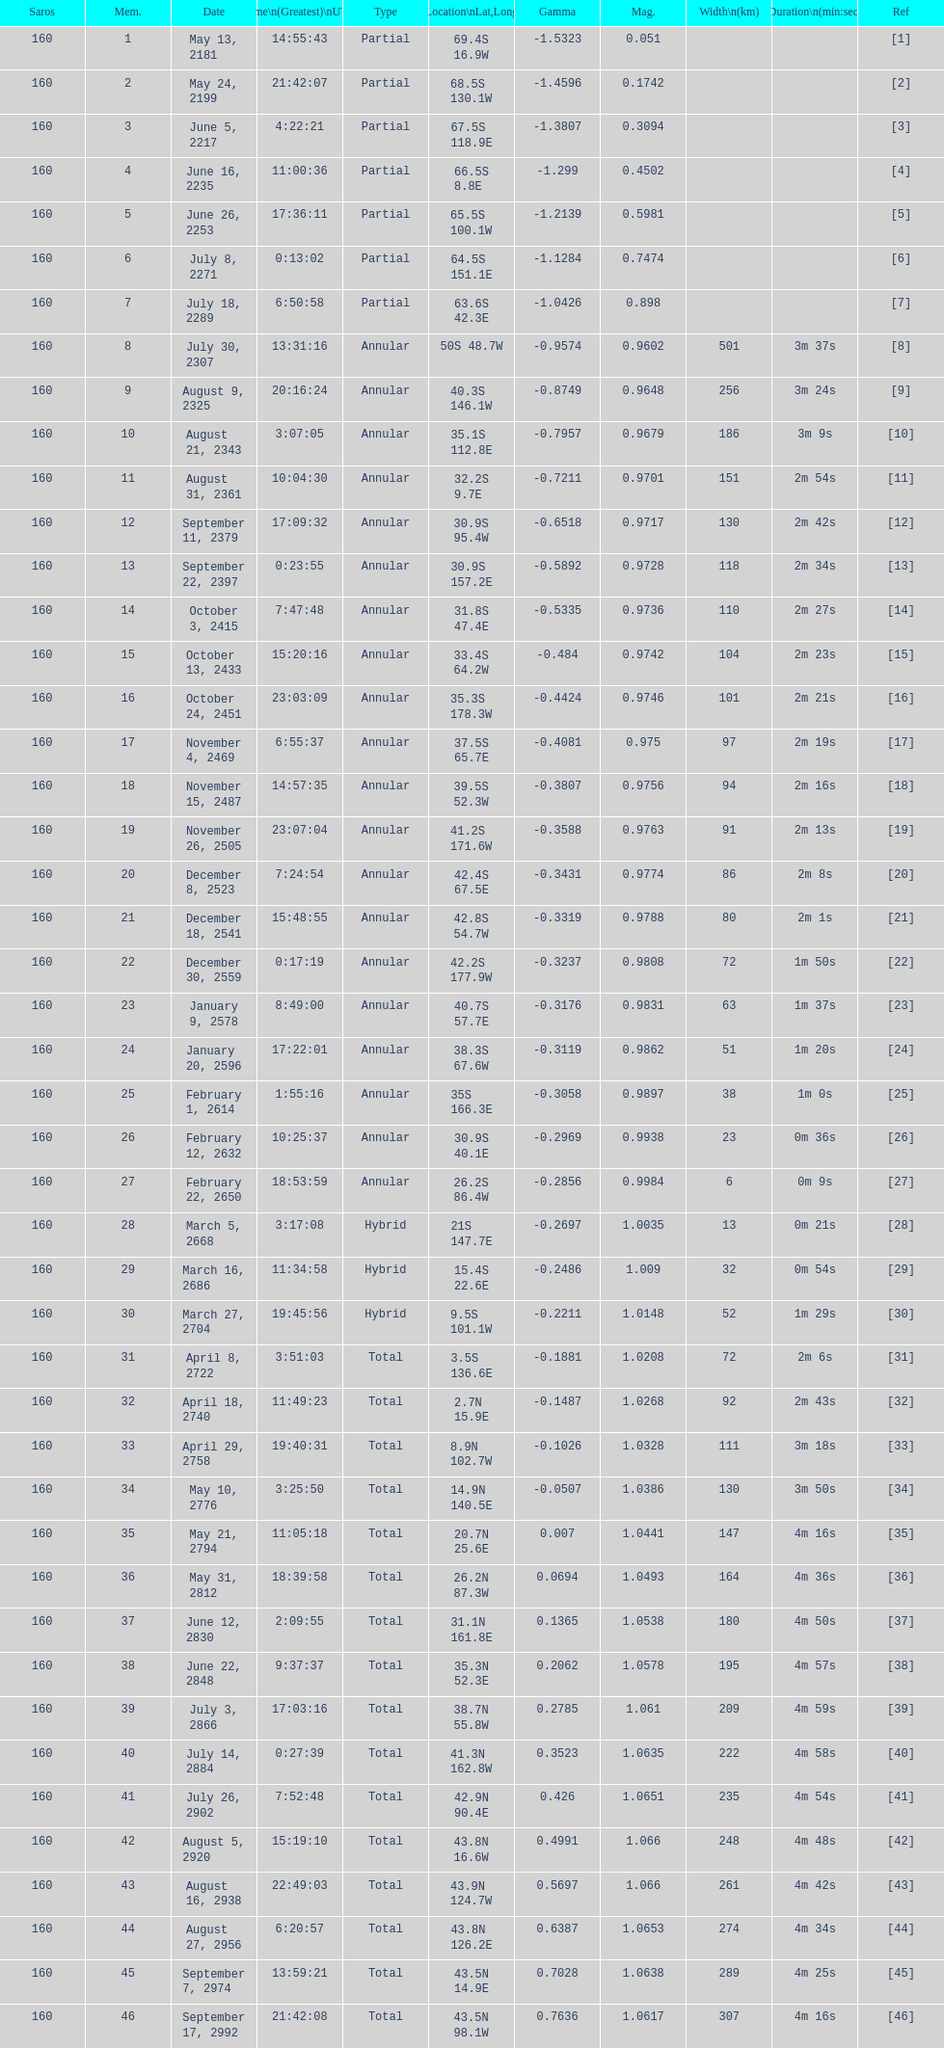Would you be able to parse every entry in this table? {'header': ['Saros', 'Mem.', 'Date', 'Time\\n(Greatest)\\nUTC', 'Type', 'Location\\nLat,Long', 'Gamma', 'Mag.', 'Width\\n(km)', 'Duration\\n(min:sec)', 'Ref'], 'rows': [['160', '1', 'May 13, 2181', '14:55:43', 'Partial', '69.4S 16.9W', '-1.5323', '0.051', '', '', '[1]'], ['160', '2', 'May 24, 2199', '21:42:07', 'Partial', '68.5S 130.1W', '-1.4596', '0.1742', '', '', '[2]'], ['160', '3', 'June 5, 2217', '4:22:21', 'Partial', '67.5S 118.9E', '-1.3807', '0.3094', '', '', '[3]'], ['160', '4', 'June 16, 2235', '11:00:36', 'Partial', '66.5S 8.8E', '-1.299', '0.4502', '', '', '[4]'], ['160', '5', 'June 26, 2253', '17:36:11', 'Partial', '65.5S 100.1W', '-1.2139', '0.5981', '', '', '[5]'], ['160', '6', 'July 8, 2271', '0:13:02', 'Partial', '64.5S 151.1E', '-1.1284', '0.7474', '', '', '[6]'], ['160', '7', 'July 18, 2289', '6:50:58', 'Partial', '63.6S 42.3E', '-1.0426', '0.898', '', '', '[7]'], ['160', '8', 'July 30, 2307', '13:31:16', 'Annular', '50S 48.7W', '-0.9574', '0.9602', '501', '3m 37s', '[8]'], ['160', '9', 'August 9, 2325', '20:16:24', 'Annular', '40.3S 146.1W', '-0.8749', '0.9648', '256', '3m 24s', '[9]'], ['160', '10', 'August 21, 2343', '3:07:05', 'Annular', '35.1S 112.8E', '-0.7957', '0.9679', '186', '3m 9s', '[10]'], ['160', '11', 'August 31, 2361', '10:04:30', 'Annular', '32.2S 9.7E', '-0.7211', '0.9701', '151', '2m 54s', '[11]'], ['160', '12', 'September 11, 2379', '17:09:32', 'Annular', '30.9S 95.4W', '-0.6518', '0.9717', '130', '2m 42s', '[12]'], ['160', '13', 'September 22, 2397', '0:23:55', 'Annular', '30.9S 157.2E', '-0.5892', '0.9728', '118', '2m 34s', '[13]'], ['160', '14', 'October 3, 2415', '7:47:48', 'Annular', '31.8S 47.4E', '-0.5335', '0.9736', '110', '2m 27s', '[14]'], ['160', '15', 'October 13, 2433', '15:20:16', 'Annular', '33.4S 64.2W', '-0.484', '0.9742', '104', '2m 23s', '[15]'], ['160', '16', 'October 24, 2451', '23:03:09', 'Annular', '35.3S 178.3W', '-0.4424', '0.9746', '101', '2m 21s', '[16]'], ['160', '17', 'November 4, 2469', '6:55:37', 'Annular', '37.5S 65.7E', '-0.4081', '0.975', '97', '2m 19s', '[17]'], ['160', '18', 'November 15, 2487', '14:57:35', 'Annular', '39.5S 52.3W', '-0.3807', '0.9756', '94', '2m 16s', '[18]'], ['160', '19', 'November 26, 2505', '23:07:04', 'Annular', '41.2S 171.6W', '-0.3588', '0.9763', '91', '2m 13s', '[19]'], ['160', '20', 'December 8, 2523', '7:24:54', 'Annular', '42.4S 67.5E', '-0.3431', '0.9774', '86', '2m 8s', '[20]'], ['160', '21', 'December 18, 2541', '15:48:55', 'Annular', '42.8S 54.7W', '-0.3319', '0.9788', '80', '2m 1s', '[21]'], ['160', '22', 'December 30, 2559', '0:17:19', 'Annular', '42.2S 177.9W', '-0.3237', '0.9808', '72', '1m 50s', '[22]'], ['160', '23', 'January 9, 2578', '8:49:00', 'Annular', '40.7S 57.7E', '-0.3176', '0.9831', '63', '1m 37s', '[23]'], ['160', '24', 'January 20, 2596', '17:22:01', 'Annular', '38.3S 67.6W', '-0.3119', '0.9862', '51', '1m 20s', '[24]'], ['160', '25', 'February 1, 2614', '1:55:16', 'Annular', '35S 166.3E', '-0.3058', '0.9897', '38', '1m 0s', '[25]'], ['160', '26', 'February 12, 2632', '10:25:37', 'Annular', '30.9S 40.1E', '-0.2969', '0.9938', '23', '0m 36s', '[26]'], ['160', '27', 'February 22, 2650', '18:53:59', 'Annular', '26.2S 86.4W', '-0.2856', '0.9984', '6', '0m 9s', '[27]'], ['160', '28', 'March 5, 2668', '3:17:08', 'Hybrid', '21S 147.7E', '-0.2697', '1.0035', '13', '0m 21s', '[28]'], ['160', '29', 'March 16, 2686', '11:34:58', 'Hybrid', '15.4S 22.6E', '-0.2486', '1.009', '32', '0m 54s', '[29]'], ['160', '30', 'March 27, 2704', '19:45:56', 'Hybrid', '9.5S 101.1W', '-0.2211', '1.0148', '52', '1m 29s', '[30]'], ['160', '31', 'April 8, 2722', '3:51:03', 'Total', '3.5S 136.6E', '-0.1881', '1.0208', '72', '2m 6s', '[31]'], ['160', '32', 'April 18, 2740', '11:49:23', 'Total', '2.7N 15.9E', '-0.1487', '1.0268', '92', '2m 43s', '[32]'], ['160', '33', 'April 29, 2758', '19:40:31', 'Total', '8.9N 102.7W', '-0.1026', '1.0328', '111', '3m 18s', '[33]'], ['160', '34', 'May 10, 2776', '3:25:50', 'Total', '14.9N 140.5E', '-0.0507', '1.0386', '130', '3m 50s', '[34]'], ['160', '35', 'May 21, 2794', '11:05:18', 'Total', '20.7N 25.6E', '0.007', '1.0441', '147', '4m 16s', '[35]'], ['160', '36', 'May 31, 2812', '18:39:58', 'Total', '26.2N 87.3W', '0.0694', '1.0493', '164', '4m 36s', '[36]'], ['160', '37', 'June 12, 2830', '2:09:55', 'Total', '31.1N 161.8E', '0.1365', '1.0538', '180', '4m 50s', '[37]'], ['160', '38', 'June 22, 2848', '9:37:37', 'Total', '35.3N 52.3E', '0.2062', '1.0578', '195', '4m 57s', '[38]'], ['160', '39', 'July 3, 2866', '17:03:16', 'Total', '38.7N 55.8W', '0.2785', '1.061', '209', '4m 59s', '[39]'], ['160', '40', 'July 14, 2884', '0:27:39', 'Total', '41.3N 162.8W', '0.3523', '1.0635', '222', '4m 58s', '[40]'], ['160', '41', 'July 26, 2902', '7:52:48', 'Total', '42.9N 90.4E', '0.426', '1.0651', '235', '4m 54s', '[41]'], ['160', '42', 'August 5, 2920', '15:19:10', 'Total', '43.8N 16.6W', '0.4991', '1.066', '248', '4m 48s', '[42]'], ['160', '43', 'August 16, 2938', '22:49:03', 'Total', '43.9N 124.7W', '0.5697', '1.066', '261', '4m 42s', '[43]'], ['160', '44', 'August 27, 2956', '6:20:57', 'Total', '43.8N 126.2E', '0.6387', '1.0653', '274', '4m 34s', '[44]'], ['160', '45', 'September 7, 2974', '13:59:21', 'Total', '43.5N 14.9E', '0.7028', '1.0638', '289', '4m 25s', '[45]'], ['160', '46', 'September 17, 2992', '21:42:08', 'Total', '43.5N 98.1W', '0.7636', '1.0617', '307', '4m 16s', '[46]']]} How long did the the saros on july 30, 2307 last for? 3m 37s. 